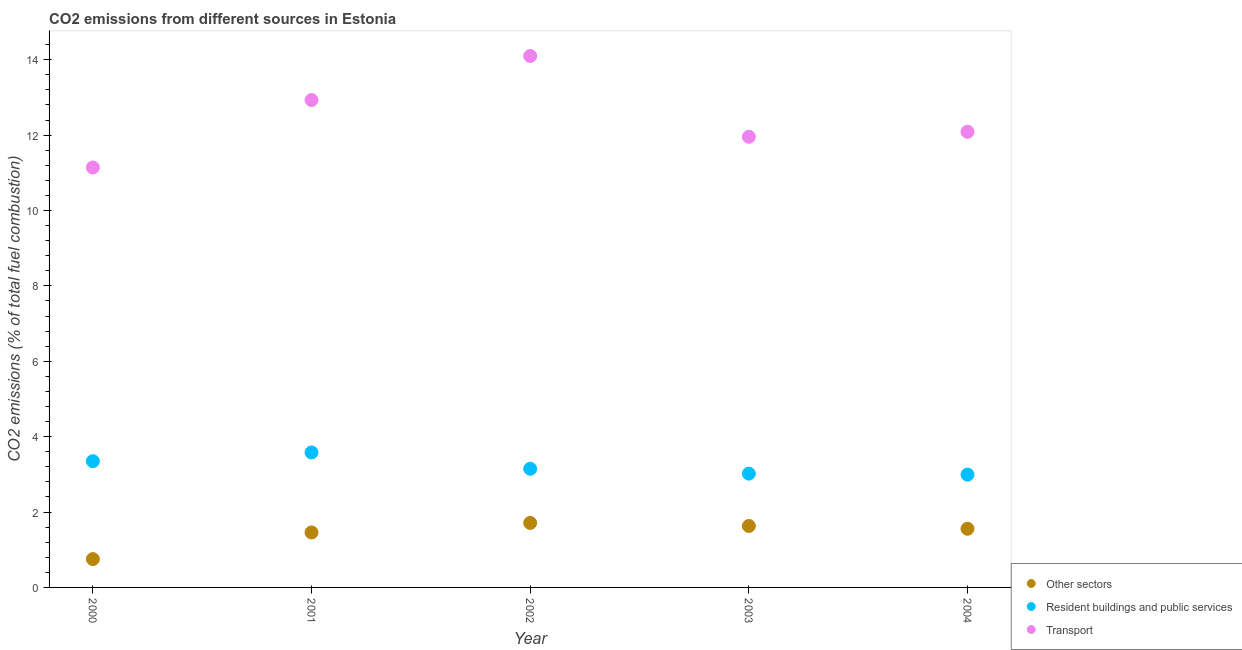How many different coloured dotlines are there?
Provide a succinct answer. 3. What is the percentage of co2 emissions from resident buildings and public services in 2004?
Ensure brevity in your answer.  2.99. Across all years, what is the maximum percentage of co2 emissions from transport?
Provide a succinct answer. 14.1. Across all years, what is the minimum percentage of co2 emissions from resident buildings and public services?
Make the answer very short. 2.99. In which year was the percentage of co2 emissions from resident buildings and public services minimum?
Your answer should be very brief. 2004. What is the total percentage of co2 emissions from resident buildings and public services in the graph?
Keep it short and to the point. 16.09. What is the difference between the percentage of co2 emissions from transport in 2000 and that in 2001?
Provide a succinct answer. -1.79. What is the difference between the percentage of co2 emissions from resident buildings and public services in 2003 and the percentage of co2 emissions from transport in 2004?
Provide a short and direct response. -9.07. What is the average percentage of co2 emissions from other sectors per year?
Your answer should be very brief. 1.42. In the year 2000, what is the difference between the percentage of co2 emissions from transport and percentage of co2 emissions from resident buildings and public services?
Offer a terse response. 7.79. What is the ratio of the percentage of co2 emissions from resident buildings and public services in 2000 to that in 2003?
Offer a terse response. 1.11. Is the percentage of co2 emissions from resident buildings and public services in 2001 less than that in 2003?
Keep it short and to the point. No. Is the difference between the percentage of co2 emissions from resident buildings and public services in 2000 and 2004 greater than the difference between the percentage of co2 emissions from other sectors in 2000 and 2004?
Provide a succinct answer. Yes. What is the difference between the highest and the second highest percentage of co2 emissions from transport?
Your answer should be very brief. 1.17. What is the difference between the highest and the lowest percentage of co2 emissions from transport?
Offer a terse response. 2.96. Does the percentage of co2 emissions from resident buildings and public services monotonically increase over the years?
Give a very brief answer. No. Is the percentage of co2 emissions from other sectors strictly greater than the percentage of co2 emissions from transport over the years?
Offer a terse response. No. Is the percentage of co2 emissions from other sectors strictly less than the percentage of co2 emissions from transport over the years?
Your answer should be compact. Yes. Are the values on the major ticks of Y-axis written in scientific E-notation?
Your answer should be compact. No. Does the graph contain grids?
Your answer should be very brief. No. How are the legend labels stacked?
Provide a short and direct response. Vertical. What is the title of the graph?
Keep it short and to the point. CO2 emissions from different sources in Estonia. Does "Wage workers" appear as one of the legend labels in the graph?
Your answer should be very brief. No. What is the label or title of the Y-axis?
Provide a short and direct response. CO2 emissions (% of total fuel combustion). What is the CO2 emissions (% of total fuel combustion) in Other sectors in 2000?
Offer a terse response. 0.75. What is the CO2 emissions (% of total fuel combustion) of Resident buildings and public services in 2000?
Your answer should be compact. 3.35. What is the CO2 emissions (% of total fuel combustion) in Transport in 2000?
Keep it short and to the point. 11.14. What is the CO2 emissions (% of total fuel combustion) of Other sectors in 2001?
Offer a terse response. 1.46. What is the CO2 emissions (% of total fuel combustion) of Resident buildings and public services in 2001?
Provide a short and direct response. 3.58. What is the CO2 emissions (% of total fuel combustion) of Transport in 2001?
Your response must be concise. 12.93. What is the CO2 emissions (% of total fuel combustion) in Other sectors in 2002?
Your answer should be compact. 1.71. What is the CO2 emissions (% of total fuel combustion) of Resident buildings and public services in 2002?
Your answer should be compact. 3.15. What is the CO2 emissions (% of total fuel combustion) in Transport in 2002?
Make the answer very short. 14.1. What is the CO2 emissions (% of total fuel combustion) of Other sectors in 2003?
Make the answer very short. 1.63. What is the CO2 emissions (% of total fuel combustion) in Resident buildings and public services in 2003?
Provide a succinct answer. 3.02. What is the CO2 emissions (% of total fuel combustion) in Transport in 2003?
Keep it short and to the point. 11.96. What is the CO2 emissions (% of total fuel combustion) of Other sectors in 2004?
Provide a succinct answer. 1.56. What is the CO2 emissions (% of total fuel combustion) of Resident buildings and public services in 2004?
Offer a very short reply. 2.99. What is the CO2 emissions (% of total fuel combustion) of Transport in 2004?
Your answer should be compact. 12.09. Across all years, what is the maximum CO2 emissions (% of total fuel combustion) in Other sectors?
Make the answer very short. 1.71. Across all years, what is the maximum CO2 emissions (% of total fuel combustion) in Resident buildings and public services?
Offer a very short reply. 3.58. Across all years, what is the maximum CO2 emissions (% of total fuel combustion) of Transport?
Give a very brief answer. 14.1. Across all years, what is the minimum CO2 emissions (% of total fuel combustion) in Other sectors?
Give a very brief answer. 0.75. Across all years, what is the minimum CO2 emissions (% of total fuel combustion) in Resident buildings and public services?
Your response must be concise. 2.99. Across all years, what is the minimum CO2 emissions (% of total fuel combustion) in Transport?
Your answer should be very brief. 11.14. What is the total CO2 emissions (% of total fuel combustion) in Other sectors in the graph?
Your answer should be compact. 7.11. What is the total CO2 emissions (% of total fuel combustion) in Resident buildings and public services in the graph?
Ensure brevity in your answer.  16.09. What is the total CO2 emissions (% of total fuel combustion) of Transport in the graph?
Your response must be concise. 62.22. What is the difference between the CO2 emissions (% of total fuel combustion) of Other sectors in 2000 and that in 2001?
Keep it short and to the point. -0.71. What is the difference between the CO2 emissions (% of total fuel combustion) in Resident buildings and public services in 2000 and that in 2001?
Offer a very short reply. -0.23. What is the difference between the CO2 emissions (% of total fuel combustion) of Transport in 2000 and that in 2001?
Provide a short and direct response. -1.79. What is the difference between the CO2 emissions (% of total fuel combustion) of Other sectors in 2000 and that in 2002?
Your response must be concise. -0.96. What is the difference between the CO2 emissions (% of total fuel combustion) in Resident buildings and public services in 2000 and that in 2002?
Provide a short and direct response. 0.2. What is the difference between the CO2 emissions (% of total fuel combustion) of Transport in 2000 and that in 2002?
Keep it short and to the point. -2.96. What is the difference between the CO2 emissions (% of total fuel combustion) of Other sectors in 2000 and that in 2003?
Your answer should be very brief. -0.88. What is the difference between the CO2 emissions (% of total fuel combustion) in Resident buildings and public services in 2000 and that in 2003?
Your answer should be compact. 0.33. What is the difference between the CO2 emissions (% of total fuel combustion) in Transport in 2000 and that in 2003?
Offer a very short reply. -0.81. What is the difference between the CO2 emissions (% of total fuel combustion) in Other sectors in 2000 and that in 2004?
Your answer should be compact. -0.8. What is the difference between the CO2 emissions (% of total fuel combustion) in Resident buildings and public services in 2000 and that in 2004?
Offer a terse response. 0.36. What is the difference between the CO2 emissions (% of total fuel combustion) in Transport in 2000 and that in 2004?
Offer a very short reply. -0.95. What is the difference between the CO2 emissions (% of total fuel combustion) of Other sectors in 2001 and that in 2002?
Give a very brief answer. -0.25. What is the difference between the CO2 emissions (% of total fuel combustion) in Resident buildings and public services in 2001 and that in 2002?
Your answer should be very brief. 0.43. What is the difference between the CO2 emissions (% of total fuel combustion) of Transport in 2001 and that in 2002?
Give a very brief answer. -1.17. What is the difference between the CO2 emissions (% of total fuel combustion) of Other sectors in 2001 and that in 2003?
Keep it short and to the point. -0.17. What is the difference between the CO2 emissions (% of total fuel combustion) of Resident buildings and public services in 2001 and that in 2003?
Ensure brevity in your answer.  0.56. What is the difference between the CO2 emissions (% of total fuel combustion) in Transport in 2001 and that in 2003?
Keep it short and to the point. 0.97. What is the difference between the CO2 emissions (% of total fuel combustion) in Other sectors in 2001 and that in 2004?
Offer a very short reply. -0.1. What is the difference between the CO2 emissions (% of total fuel combustion) in Resident buildings and public services in 2001 and that in 2004?
Keep it short and to the point. 0.59. What is the difference between the CO2 emissions (% of total fuel combustion) of Transport in 2001 and that in 2004?
Provide a short and direct response. 0.84. What is the difference between the CO2 emissions (% of total fuel combustion) in Other sectors in 2002 and that in 2003?
Make the answer very short. 0.08. What is the difference between the CO2 emissions (% of total fuel combustion) of Resident buildings and public services in 2002 and that in 2003?
Your answer should be very brief. 0.13. What is the difference between the CO2 emissions (% of total fuel combustion) of Transport in 2002 and that in 2003?
Keep it short and to the point. 2.14. What is the difference between the CO2 emissions (% of total fuel combustion) of Other sectors in 2002 and that in 2004?
Offer a very short reply. 0.16. What is the difference between the CO2 emissions (% of total fuel combustion) of Resident buildings and public services in 2002 and that in 2004?
Your response must be concise. 0.16. What is the difference between the CO2 emissions (% of total fuel combustion) in Transport in 2002 and that in 2004?
Give a very brief answer. 2.01. What is the difference between the CO2 emissions (% of total fuel combustion) of Other sectors in 2003 and that in 2004?
Offer a very short reply. 0.07. What is the difference between the CO2 emissions (% of total fuel combustion) of Resident buildings and public services in 2003 and that in 2004?
Ensure brevity in your answer.  0.03. What is the difference between the CO2 emissions (% of total fuel combustion) of Transport in 2003 and that in 2004?
Provide a succinct answer. -0.13. What is the difference between the CO2 emissions (% of total fuel combustion) of Other sectors in 2000 and the CO2 emissions (% of total fuel combustion) of Resident buildings and public services in 2001?
Your answer should be compact. -2.83. What is the difference between the CO2 emissions (% of total fuel combustion) of Other sectors in 2000 and the CO2 emissions (% of total fuel combustion) of Transport in 2001?
Keep it short and to the point. -12.18. What is the difference between the CO2 emissions (% of total fuel combustion) of Resident buildings and public services in 2000 and the CO2 emissions (% of total fuel combustion) of Transport in 2001?
Your answer should be compact. -9.58. What is the difference between the CO2 emissions (% of total fuel combustion) of Other sectors in 2000 and the CO2 emissions (% of total fuel combustion) of Resident buildings and public services in 2002?
Give a very brief answer. -2.4. What is the difference between the CO2 emissions (% of total fuel combustion) in Other sectors in 2000 and the CO2 emissions (% of total fuel combustion) in Transport in 2002?
Provide a short and direct response. -13.35. What is the difference between the CO2 emissions (% of total fuel combustion) in Resident buildings and public services in 2000 and the CO2 emissions (% of total fuel combustion) in Transport in 2002?
Offer a terse response. -10.75. What is the difference between the CO2 emissions (% of total fuel combustion) of Other sectors in 2000 and the CO2 emissions (% of total fuel combustion) of Resident buildings and public services in 2003?
Provide a succinct answer. -2.27. What is the difference between the CO2 emissions (% of total fuel combustion) of Other sectors in 2000 and the CO2 emissions (% of total fuel combustion) of Transport in 2003?
Provide a short and direct response. -11.2. What is the difference between the CO2 emissions (% of total fuel combustion) of Resident buildings and public services in 2000 and the CO2 emissions (% of total fuel combustion) of Transport in 2003?
Ensure brevity in your answer.  -8.61. What is the difference between the CO2 emissions (% of total fuel combustion) in Other sectors in 2000 and the CO2 emissions (% of total fuel combustion) in Resident buildings and public services in 2004?
Give a very brief answer. -2.24. What is the difference between the CO2 emissions (% of total fuel combustion) in Other sectors in 2000 and the CO2 emissions (% of total fuel combustion) in Transport in 2004?
Keep it short and to the point. -11.34. What is the difference between the CO2 emissions (% of total fuel combustion) in Resident buildings and public services in 2000 and the CO2 emissions (% of total fuel combustion) in Transport in 2004?
Make the answer very short. -8.74. What is the difference between the CO2 emissions (% of total fuel combustion) of Other sectors in 2001 and the CO2 emissions (% of total fuel combustion) of Resident buildings and public services in 2002?
Offer a very short reply. -1.69. What is the difference between the CO2 emissions (% of total fuel combustion) of Other sectors in 2001 and the CO2 emissions (% of total fuel combustion) of Transport in 2002?
Offer a very short reply. -12.64. What is the difference between the CO2 emissions (% of total fuel combustion) in Resident buildings and public services in 2001 and the CO2 emissions (% of total fuel combustion) in Transport in 2002?
Provide a succinct answer. -10.52. What is the difference between the CO2 emissions (% of total fuel combustion) in Other sectors in 2001 and the CO2 emissions (% of total fuel combustion) in Resident buildings and public services in 2003?
Your answer should be very brief. -1.56. What is the difference between the CO2 emissions (% of total fuel combustion) in Other sectors in 2001 and the CO2 emissions (% of total fuel combustion) in Transport in 2003?
Offer a terse response. -10.5. What is the difference between the CO2 emissions (% of total fuel combustion) in Resident buildings and public services in 2001 and the CO2 emissions (% of total fuel combustion) in Transport in 2003?
Offer a very short reply. -8.38. What is the difference between the CO2 emissions (% of total fuel combustion) in Other sectors in 2001 and the CO2 emissions (% of total fuel combustion) in Resident buildings and public services in 2004?
Ensure brevity in your answer.  -1.53. What is the difference between the CO2 emissions (% of total fuel combustion) of Other sectors in 2001 and the CO2 emissions (% of total fuel combustion) of Transport in 2004?
Give a very brief answer. -10.63. What is the difference between the CO2 emissions (% of total fuel combustion) in Resident buildings and public services in 2001 and the CO2 emissions (% of total fuel combustion) in Transport in 2004?
Provide a succinct answer. -8.51. What is the difference between the CO2 emissions (% of total fuel combustion) of Other sectors in 2002 and the CO2 emissions (% of total fuel combustion) of Resident buildings and public services in 2003?
Offer a terse response. -1.31. What is the difference between the CO2 emissions (% of total fuel combustion) in Other sectors in 2002 and the CO2 emissions (% of total fuel combustion) in Transport in 2003?
Your answer should be very brief. -10.25. What is the difference between the CO2 emissions (% of total fuel combustion) of Resident buildings and public services in 2002 and the CO2 emissions (% of total fuel combustion) of Transport in 2003?
Provide a short and direct response. -8.81. What is the difference between the CO2 emissions (% of total fuel combustion) of Other sectors in 2002 and the CO2 emissions (% of total fuel combustion) of Resident buildings and public services in 2004?
Make the answer very short. -1.28. What is the difference between the CO2 emissions (% of total fuel combustion) in Other sectors in 2002 and the CO2 emissions (% of total fuel combustion) in Transport in 2004?
Your answer should be compact. -10.38. What is the difference between the CO2 emissions (% of total fuel combustion) in Resident buildings and public services in 2002 and the CO2 emissions (% of total fuel combustion) in Transport in 2004?
Give a very brief answer. -8.94. What is the difference between the CO2 emissions (% of total fuel combustion) of Other sectors in 2003 and the CO2 emissions (% of total fuel combustion) of Resident buildings and public services in 2004?
Keep it short and to the point. -1.36. What is the difference between the CO2 emissions (% of total fuel combustion) of Other sectors in 2003 and the CO2 emissions (% of total fuel combustion) of Transport in 2004?
Provide a short and direct response. -10.46. What is the difference between the CO2 emissions (% of total fuel combustion) in Resident buildings and public services in 2003 and the CO2 emissions (% of total fuel combustion) in Transport in 2004?
Your response must be concise. -9.07. What is the average CO2 emissions (% of total fuel combustion) in Other sectors per year?
Ensure brevity in your answer.  1.42. What is the average CO2 emissions (% of total fuel combustion) of Resident buildings and public services per year?
Provide a short and direct response. 3.22. What is the average CO2 emissions (% of total fuel combustion) in Transport per year?
Offer a very short reply. 12.44. In the year 2000, what is the difference between the CO2 emissions (% of total fuel combustion) in Other sectors and CO2 emissions (% of total fuel combustion) in Resident buildings and public services?
Offer a very short reply. -2.6. In the year 2000, what is the difference between the CO2 emissions (% of total fuel combustion) of Other sectors and CO2 emissions (% of total fuel combustion) of Transport?
Make the answer very short. -10.39. In the year 2000, what is the difference between the CO2 emissions (% of total fuel combustion) in Resident buildings and public services and CO2 emissions (% of total fuel combustion) in Transport?
Your answer should be very brief. -7.79. In the year 2001, what is the difference between the CO2 emissions (% of total fuel combustion) of Other sectors and CO2 emissions (% of total fuel combustion) of Resident buildings and public services?
Your answer should be very brief. -2.12. In the year 2001, what is the difference between the CO2 emissions (% of total fuel combustion) of Other sectors and CO2 emissions (% of total fuel combustion) of Transport?
Provide a short and direct response. -11.47. In the year 2001, what is the difference between the CO2 emissions (% of total fuel combustion) in Resident buildings and public services and CO2 emissions (% of total fuel combustion) in Transport?
Provide a succinct answer. -9.35. In the year 2002, what is the difference between the CO2 emissions (% of total fuel combustion) of Other sectors and CO2 emissions (% of total fuel combustion) of Resident buildings and public services?
Offer a very short reply. -1.44. In the year 2002, what is the difference between the CO2 emissions (% of total fuel combustion) in Other sectors and CO2 emissions (% of total fuel combustion) in Transport?
Offer a very short reply. -12.39. In the year 2002, what is the difference between the CO2 emissions (% of total fuel combustion) of Resident buildings and public services and CO2 emissions (% of total fuel combustion) of Transport?
Ensure brevity in your answer.  -10.95. In the year 2003, what is the difference between the CO2 emissions (% of total fuel combustion) of Other sectors and CO2 emissions (% of total fuel combustion) of Resident buildings and public services?
Make the answer very short. -1.39. In the year 2003, what is the difference between the CO2 emissions (% of total fuel combustion) in Other sectors and CO2 emissions (% of total fuel combustion) in Transport?
Ensure brevity in your answer.  -10.33. In the year 2003, what is the difference between the CO2 emissions (% of total fuel combustion) in Resident buildings and public services and CO2 emissions (% of total fuel combustion) in Transport?
Your response must be concise. -8.94. In the year 2004, what is the difference between the CO2 emissions (% of total fuel combustion) in Other sectors and CO2 emissions (% of total fuel combustion) in Resident buildings and public services?
Give a very brief answer. -1.44. In the year 2004, what is the difference between the CO2 emissions (% of total fuel combustion) of Other sectors and CO2 emissions (% of total fuel combustion) of Transport?
Provide a short and direct response. -10.53. In the year 2004, what is the difference between the CO2 emissions (% of total fuel combustion) in Resident buildings and public services and CO2 emissions (% of total fuel combustion) in Transport?
Your answer should be very brief. -9.1. What is the ratio of the CO2 emissions (% of total fuel combustion) of Other sectors in 2000 to that in 2001?
Ensure brevity in your answer.  0.52. What is the ratio of the CO2 emissions (% of total fuel combustion) of Resident buildings and public services in 2000 to that in 2001?
Provide a short and direct response. 0.94. What is the ratio of the CO2 emissions (% of total fuel combustion) in Transport in 2000 to that in 2001?
Offer a terse response. 0.86. What is the ratio of the CO2 emissions (% of total fuel combustion) of Other sectors in 2000 to that in 2002?
Offer a terse response. 0.44. What is the ratio of the CO2 emissions (% of total fuel combustion) of Resident buildings and public services in 2000 to that in 2002?
Provide a short and direct response. 1.06. What is the ratio of the CO2 emissions (% of total fuel combustion) of Transport in 2000 to that in 2002?
Offer a very short reply. 0.79. What is the ratio of the CO2 emissions (% of total fuel combustion) of Other sectors in 2000 to that in 2003?
Your answer should be very brief. 0.46. What is the ratio of the CO2 emissions (% of total fuel combustion) in Resident buildings and public services in 2000 to that in 2003?
Ensure brevity in your answer.  1.11. What is the ratio of the CO2 emissions (% of total fuel combustion) in Transport in 2000 to that in 2003?
Your answer should be compact. 0.93. What is the ratio of the CO2 emissions (% of total fuel combustion) in Other sectors in 2000 to that in 2004?
Your response must be concise. 0.48. What is the ratio of the CO2 emissions (% of total fuel combustion) in Resident buildings and public services in 2000 to that in 2004?
Your answer should be compact. 1.12. What is the ratio of the CO2 emissions (% of total fuel combustion) of Transport in 2000 to that in 2004?
Your response must be concise. 0.92. What is the ratio of the CO2 emissions (% of total fuel combustion) in Other sectors in 2001 to that in 2002?
Offer a terse response. 0.85. What is the ratio of the CO2 emissions (% of total fuel combustion) of Resident buildings and public services in 2001 to that in 2002?
Offer a terse response. 1.14. What is the ratio of the CO2 emissions (% of total fuel combustion) in Transport in 2001 to that in 2002?
Your response must be concise. 0.92. What is the ratio of the CO2 emissions (% of total fuel combustion) in Other sectors in 2001 to that in 2003?
Ensure brevity in your answer.  0.89. What is the ratio of the CO2 emissions (% of total fuel combustion) in Resident buildings and public services in 2001 to that in 2003?
Provide a succinct answer. 1.19. What is the ratio of the CO2 emissions (% of total fuel combustion) of Transport in 2001 to that in 2003?
Ensure brevity in your answer.  1.08. What is the ratio of the CO2 emissions (% of total fuel combustion) in Other sectors in 2001 to that in 2004?
Your response must be concise. 0.94. What is the ratio of the CO2 emissions (% of total fuel combustion) in Resident buildings and public services in 2001 to that in 2004?
Your answer should be compact. 1.2. What is the ratio of the CO2 emissions (% of total fuel combustion) in Transport in 2001 to that in 2004?
Ensure brevity in your answer.  1.07. What is the ratio of the CO2 emissions (% of total fuel combustion) of Other sectors in 2002 to that in 2003?
Your answer should be very brief. 1.05. What is the ratio of the CO2 emissions (% of total fuel combustion) of Resident buildings and public services in 2002 to that in 2003?
Your answer should be very brief. 1.04. What is the ratio of the CO2 emissions (% of total fuel combustion) in Transport in 2002 to that in 2003?
Your response must be concise. 1.18. What is the ratio of the CO2 emissions (% of total fuel combustion) in Other sectors in 2002 to that in 2004?
Provide a succinct answer. 1.1. What is the ratio of the CO2 emissions (% of total fuel combustion) in Resident buildings and public services in 2002 to that in 2004?
Provide a succinct answer. 1.05. What is the ratio of the CO2 emissions (% of total fuel combustion) in Transport in 2002 to that in 2004?
Provide a short and direct response. 1.17. What is the ratio of the CO2 emissions (% of total fuel combustion) of Other sectors in 2003 to that in 2004?
Your answer should be very brief. 1.05. What is the ratio of the CO2 emissions (% of total fuel combustion) of Resident buildings and public services in 2003 to that in 2004?
Keep it short and to the point. 1.01. What is the ratio of the CO2 emissions (% of total fuel combustion) of Transport in 2003 to that in 2004?
Make the answer very short. 0.99. What is the difference between the highest and the second highest CO2 emissions (% of total fuel combustion) of Other sectors?
Your answer should be compact. 0.08. What is the difference between the highest and the second highest CO2 emissions (% of total fuel combustion) in Resident buildings and public services?
Your answer should be compact. 0.23. What is the difference between the highest and the second highest CO2 emissions (% of total fuel combustion) of Transport?
Your answer should be compact. 1.17. What is the difference between the highest and the lowest CO2 emissions (% of total fuel combustion) of Other sectors?
Your response must be concise. 0.96. What is the difference between the highest and the lowest CO2 emissions (% of total fuel combustion) in Resident buildings and public services?
Offer a very short reply. 0.59. What is the difference between the highest and the lowest CO2 emissions (% of total fuel combustion) in Transport?
Offer a terse response. 2.96. 